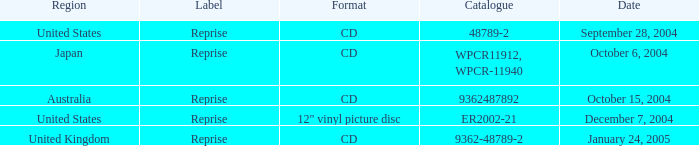Name the region for december 7, 2004 United States. 